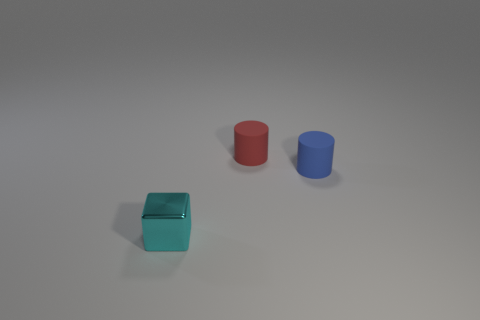How many things are small objects behind the cyan block or tiny metal objects?
Offer a very short reply. 3. Are there fewer metal objects than large red metallic spheres?
Provide a short and direct response. No. There is a small thing that is the same material as the small blue cylinder; what is its shape?
Keep it short and to the point. Cylinder. Are there any metallic blocks to the left of the cyan cube?
Give a very brief answer. No. Is the number of shiny blocks that are behind the cyan object less than the number of metal objects?
Keep it short and to the point. Yes. What is the small red cylinder made of?
Your answer should be very brief. Rubber. What color is the metal cube?
Provide a succinct answer. Cyan. What color is the small thing that is both to the left of the tiny blue thing and behind the cube?
Provide a succinct answer. Red. Is there any other thing that is made of the same material as the red object?
Provide a succinct answer. Yes. Are the blue object and the cylinder left of the blue matte thing made of the same material?
Provide a short and direct response. Yes. 